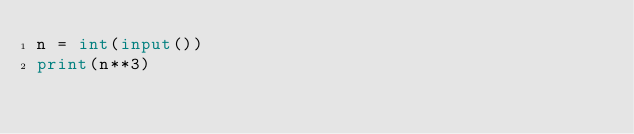<code> <loc_0><loc_0><loc_500><loc_500><_Python_>n = int(input())
print(n**3)</code> 